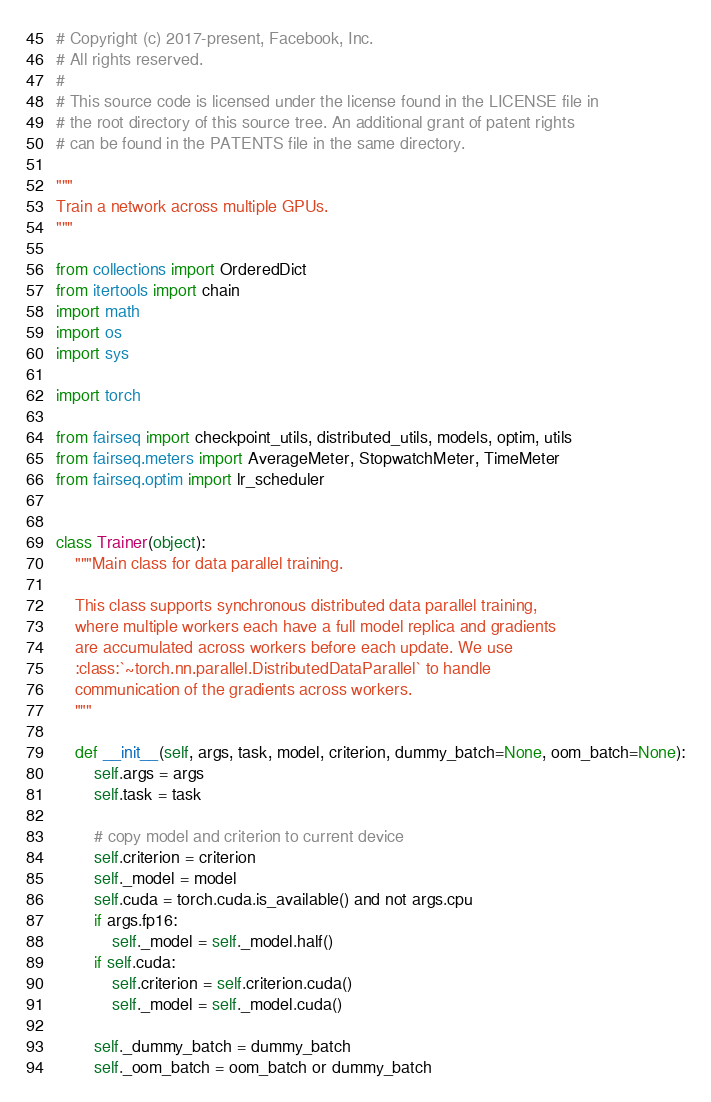<code> <loc_0><loc_0><loc_500><loc_500><_Python_># Copyright (c) 2017-present, Facebook, Inc.
# All rights reserved.
#
# This source code is licensed under the license found in the LICENSE file in
# the root directory of this source tree. An additional grant of patent rights
# can be found in the PATENTS file in the same directory.

"""
Train a network across multiple GPUs.
"""

from collections import OrderedDict
from itertools import chain
import math
import os
import sys

import torch

from fairseq import checkpoint_utils, distributed_utils, models, optim, utils
from fairseq.meters import AverageMeter, StopwatchMeter, TimeMeter
from fairseq.optim import lr_scheduler


class Trainer(object):
    """Main class for data parallel training.

    This class supports synchronous distributed data parallel training,
    where multiple workers each have a full model replica and gradients
    are accumulated across workers before each update. We use
    :class:`~torch.nn.parallel.DistributedDataParallel` to handle
    communication of the gradients across workers.
    """

    def __init__(self, args, task, model, criterion, dummy_batch=None, oom_batch=None):
        self.args = args
        self.task = task

        # copy model and criterion to current device
        self.criterion = criterion
        self._model = model
        self.cuda = torch.cuda.is_available() and not args.cpu
        if args.fp16:
            self._model = self._model.half()
        if self.cuda:
            self.criterion = self.criterion.cuda()
            self._model = self._model.cuda()

        self._dummy_batch = dummy_batch
        self._oom_batch = oom_batch or dummy_batch
</code> 